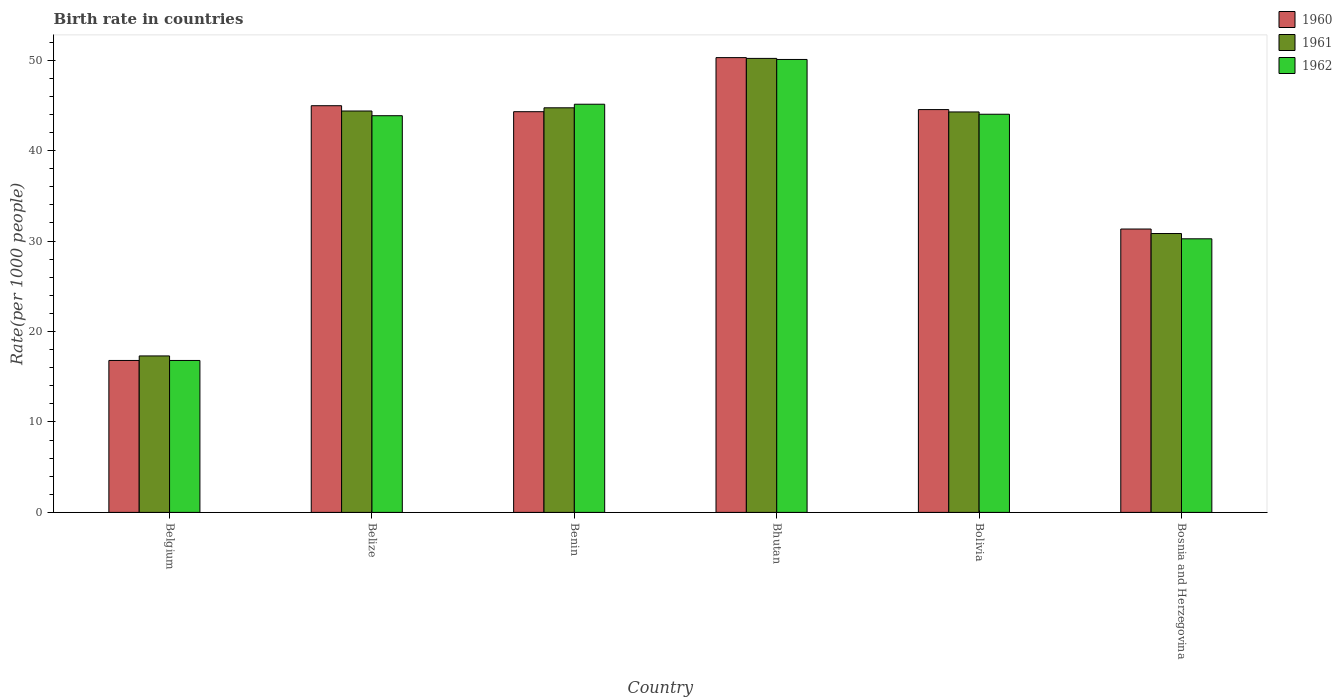How many groups of bars are there?
Offer a very short reply. 6. Are the number of bars on each tick of the X-axis equal?
Your answer should be compact. Yes. How many bars are there on the 3rd tick from the right?
Provide a short and direct response. 3. What is the label of the 2nd group of bars from the left?
Ensure brevity in your answer.  Belize. In how many cases, is the number of bars for a given country not equal to the number of legend labels?
Offer a very short reply. 0. What is the birth rate in 1960 in Bhutan?
Give a very brief answer. 50.29. Across all countries, what is the maximum birth rate in 1960?
Provide a succinct answer. 50.29. In which country was the birth rate in 1961 maximum?
Your answer should be compact. Bhutan. What is the total birth rate in 1961 in the graph?
Offer a very short reply. 231.73. What is the difference between the birth rate in 1961 in Belgium and that in Bhutan?
Make the answer very short. -32.9. What is the difference between the birth rate in 1962 in Bosnia and Herzegovina and the birth rate in 1961 in Benin?
Provide a short and direct response. -14.48. What is the average birth rate in 1962 per country?
Ensure brevity in your answer.  38.36. In how many countries, is the birth rate in 1962 greater than 24?
Offer a terse response. 5. What is the ratio of the birth rate in 1961 in Belgium to that in Bosnia and Herzegovina?
Offer a very short reply. 0.56. Is the birth rate in 1962 in Benin less than that in Bolivia?
Offer a terse response. No. What is the difference between the highest and the second highest birth rate in 1961?
Provide a succinct answer. 5.46. What is the difference between the highest and the lowest birth rate in 1961?
Your answer should be compact. 32.9. What does the 3rd bar from the left in Benin represents?
Provide a short and direct response. 1962. Is it the case that in every country, the sum of the birth rate in 1960 and birth rate in 1962 is greater than the birth rate in 1961?
Provide a succinct answer. Yes. How many bars are there?
Your answer should be compact. 18. Are all the bars in the graph horizontal?
Ensure brevity in your answer.  No. What is the difference between two consecutive major ticks on the Y-axis?
Provide a succinct answer. 10. Are the values on the major ticks of Y-axis written in scientific E-notation?
Offer a very short reply. No. Does the graph contain grids?
Make the answer very short. No. How many legend labels are there?
Offer a very short reply. 3. What is the title of the graph?
Provide a succinct answer. Birth rate in countries. What is the label or title of the Y-axis?
Offer a very short reply. Rate(per 1000 people). What is the Rate(per 1000 people) of 1960 in Belize?
Keep it short and to the point. 44.97. What is the Rate(per 1000 people) of 1961 in Belize?
Your answer should be very brief. 44.38. What is the Rate(per 1000 people) of 1962 in Belize?
Provide a short and direct response. 43.86. What is the Rate(per 1000 people) in 1960 in Benin?
Give a very brief answer. 44.31. What is the Rate(per 1000 people) of 1961 in Benin?
Your response must be concise. 44.74. What is the Rate(per 1000 people) in 1962 in Benin?
Ensure brevity in your answer.  45.13. What is the Rate(per 1000 people) in 1960 in Bhutan?
Offer a very short reply. 50.29. What is the Rate(per 1000 people) of 1961 in Bhutan?
Your response must be concise. 50.2. What is the Rate(per 1000 people) in 1962 in Bhutan?
Provide a short and direct response. 50.08. What is the Rate(per 1000 people) of 1960 in Bolivia?
Offer a very short reply. 44.54. What is the Rate(per 1000 people) of 1961 in Bolivia?
Offer a terse response. 44.28. What is the Rate(per 1000 people) of 1962 in Bolivia?
Ensure brevity in your answer.  44.02. What is the Rate(per 1000 people) of 1960 in Bosnia and Herzegovina?
Make the answer very short. 31.33. What is the Rate(per 1000 people) of 1961 in Bosnia and Herzegovina?
Keep it short and to the point. 30.84. What is the Rate(per 1000 people) of 1962 in Bosnia and Herzegovina?
Make the answer very short. 30.25. Across all countries, what is the maximum Rate(per 1000 people) in 1960?
Give a very brief answer. 50.29. Across all countries, what is the maximum Rate(per 1000 people) of 1961?
Your response must be concise. 50.2. Across all countries, what is the maximum Rate(per 1000 people) in 1962?
Your answer should be compact. 50.08. Across all countries, what is the minimum Rate(per 1000 people) in 1960?
Your response must be concise. 16.8. Across all countries, what is the minimum Rate(per 1000 people) in 1961?
Ensure brevity in your answer.  17.3. Across all countries, what is the minimum Rate(per 1000 people) in 1962?
Your answer should be very brief. 16.8. What is the total Rate(per 1000 people) in 1960 in the graph?
Offer a terse response. 232.23. What is the total Rate(per 1000 people) of 1961 in the graph?
Provide a short and direct response. 231.73. What is the total Rate(per 1000 people) of 1962 in the graph?
Offer a very short reply. 230.15. What is the difference between the Rate(per 1000 people) of 1960 in Belgium and that in Belize?
Offer a terse response. -28.17. What is the difference between the Rate(per 1000 people) of 1961 in Belgium and that in Belize?
Your response must be concise. -27.08. What is the difference between the Rate(per 1000 people) of 1962 in Belgium and that in Belize?
Your response must be concise. -27.06. What is the difference between the Rate(per 1000 people) of 1960 in Belgium and that in Benin?
Your response must be concise. -27.51. What is the difference between the Rate(per 1000 people) of 1961 in Belgium and that in Benin?
Provide a succinct answer. -27.44. What is the difference between the Rate(per 1000 people) in 1962 in Belgium and that in Benin?
Your response must be concise. -28.33. What is the difference between the Rate(per 1000 people) in 1960 in Belgium and that in Bhutan?
Keep it short and to the point. -33.49. What is the difference between the Rate(per 1000 people) of 1961 in Belgium and that in Bhutan?
Provide a short and direct response. -32.9. What is the difference between the Rate(per 1000 people) of 1962 in Belgium and that in Bhutan?
Provide a short and direct response. -33.28. What is the difference between the Rate(per 1000 people) of 1960 in Belgium and that in Bolivia?
Your answer should be very brief. -27.74. What is the difference between the Rate(per 1000 people) in 1961 in Belgium and that in Bolivia?
Make the answer very short. -26.98. What is the difference between the Rate(per 1000 people) of 1962 in Belgium and that in Bolivia?
Provide a succinct answer. -27.23. What is the difference between the Rate(per 1000 people) of 1960 in Belgium and that in Bosnia and Herzegovina?
Your answer should be very brief. -14.53. What is the difference between the Rate(per 1000 people) of 1961 in Belgium and that in Bosnia and Herzegovina?
Offer a terse response. -13.54. What is the difference between the Rate(per 1000 people) in 1962 in Belgium and that in Bosnia and Herzegovina?
Provide a short and direct response. -13.45. What is the difference between the Rate(per 1000 people) in 1960 in Belize and that in Benin?
Your answer should be very brief. 0.66. What is the difference between the Rate(per 1000 people) in 1961 in Belize and that in Benin?
Offer a very short reply. -0.35. What is the difference between the Rate(per 1000 people) of 1962 in Belize and that in Benin?
Keep it short and to the point. -1.27. What is the difference between the Rate(per 1000 people) in 1960 in Belize and that in Bhutan?
Give a very brief answer. -5.32. What is the difference between the Rate(per 1000 people) in 1961 in Belize and that in Bhutan?
Your response must be concise. -5.82. What is the difference between the Rate(per 1000 people) of 1962 in Belize and that in Bhutan?
Give a very brief answer. -6.22. What is the difference between the Rate(per 1000 people) of 1960 in Belize and that in Bolivia?
Provide a short and direct response. 0.43. What is the difference between the Rate(per 1000 people) in 1961 in Belize and that in Bolivia?
Provide a short and direct response. 0.1. What is the difference between the Rate(per 1000 people) in 1962 in Belize and that in Bolivia?
Provide a succinct answer. -0.16. What is the difference between the Rate(per 1000 people) of 1960 in Belize and that in Bosnia and Herzegovina?
Ensure brevity in your answer.  13.63. What is the difference between the Rate(per 1000 people) of 1961 in Belize and that in Bosnia and Herzegovina?
Provide a succinct answer. 13.55. What is the difference between the Rate(per 1000 people) in 1962 in Belize and that in Bosnia and Herzegovina?
Your response must be concise. 13.61. What is the difference between the Rate(per 1000 people) in 1960 in Benin and that in Bhutan?
Make the answer very short. -5.98. What is the difference between the Rate(per 1000 people) in 1961 in Benin and that in Bhutan?
Give a very brief answer. -5.46. What is the difference between the Rate(per 1000 people) of 1962 in Benin and that in Bhutan?
Offer a terse response. -4.95. What is the difference between the Rate(per 1000 people) of 1960 in Benin and that in Bolivia?
Keep it short and to the point. -0.23. What is the difference between the Rate(per 1000 people) in 1961 in Benin and that in Bolivia?
Ensure brevity in your answer.  0.46. What is the difference between the Rate(per 1000 people) in 1962 in Benin and that in Bolivia?
Ensure brevity in your answer.  1.11. What is the difference between the Rate(per 1000 people) of 1960 in Benin and that in Bosnia and Herzegovina?
Provide a short and direct response. 12.97. What is the difference between the Rate(per 1000 people) of 1961 in Benin and that in Bosnia and Herzegovina?
Your answer should be compact. 13.9. What is the difference between the Rate(per 1000 people) of 1962 in Benin and that in Bosnia and Herzegovina?
Make the answer very short. 14.88. What is the difference between the Rate(per 1000 people) in 1960 in Bhutan and that in Bolivia?
Provide a short and direct response. 5.75. What is the difference between the Rate(per 1000 people) in 1961 in Bhutan and that in Bolivia?
Give a very brief answer. 5.92. What is the difference between the Rate(per 1000 people) of 1962 in Bhutan and that in Bolivia?
Your response must be concise. 6.06. What is the difference between the Rate(per 1000 people) of 1960 in Bhutan and that in Bosnia and Herzegovina?
Your response must be concise. 18.95. What is the difference between the Rate(per 1000 people) in 1961 in Bhutan and that in Bosnia and Herzegovina?
Provide a short and direct response. 19.36. What is the difference between the Rate(per 1000 people) of 1962 in Bhutan and that in Bosnia and Herzegovina?
Provide a succinct answer. 19.83. What is the difference between the Rate(per 1000 people) in 1960 in Bolivia and that in Bosnia and Herzegovina?
Offer a very short reply. 13.21. What is the difference between the Rate(per 1000 people) of 1961 in Bolivia and that in Bosnia and Herzegovina?
Provide a succinct answer. 13.44. What is the difference between the Rate(per 1000 people) in 1962 in Bolivia and that in Bosnia and Herzegovina?
Ensure brevity in your answer.  13.77. What is the difference between the Rate(per 1000 people) in 1960 in Belgium and the Rate(per 1000 people) in 1961 in Belize?
Give a very brief answer. -27.58. What is the difference between the Rate(per 1000 people) of 1960 in Belgium and the Rate(per 1000 people) of 1962 in Belize?
Keep it short and to the point. -27.06. What is the difference between the Rate(per 1000 people) of 1961 in Belgium and the Rate(per 1000 people) of 1962 in Belize?
Your response must be concise. -26.56. What is the difference between the Rate(per 1000 people) in 1960 in Belgium and the Rate(per 1000 people) in 1961 in Benin?
Give a very brief answer. -27.94. What is the difference between the Rate(per 1000 people) of 1960 in Belgium and the Rate(per 1000 people) of 1962 in Benin?
Ensure brevity in your answer.  -28.33. What is the difference between the Rate(per 1000 people) in 1961 in Belgium and the Rate(per 1000 people) in 1962 in Benin?
Keep it short and to the point. -27.83. What is the difference between the Rate(per 1000 people) of 1960 in Belgium and the Rate(per 1000 people) of 1961 in Bhutan?
Provide a short and direct response. -33.4. What is the difference between the Rate(per 1000 people) in 1960 in Belgium and the Rate(per 1000 people) in 1962 in Bhutan?
Ensure brevity in your answer.  -33.28. What is the difference between the Rate(per 1000 people) of 1961 in Belgium and the Rate(per 1000 people) of 1962 in Bhutan?
Your answer should be very brief. -32.78. What is the difference between the Rate(per 1000 people) in 1960 in Belgium and the Rate(per 1000 people) in 1961 in Bolivia?
Make the answer very short. -27.48. What is the difference between the Rate(per 1000 people) in 1960 in Belgium and the Rate(per 1000 people) in 1962 in Bolivia?
Your answer should be compact. -27.23. What is the difference between the Rate(per 1000 people) of 1961 in Belgium and the Rate(per 1000 people) of 1962 in Bolivia?
Provide a short and direct response. -26.73. What is the difference between the Rate(per 1000 people) of 1960 in Belgium and the Rate(per 1000 people) of 1961 in Bosnia and Herzegovina?
Your response must be concise. -14.04. What is the difference between the Rate(per 1000 people) in 1960 in Belgium and the Rate(per 1000 people) in 1962 in Bosnia and Herzegovina?
Your answer should be very brief. -13.45. What is the difference between the Rate(per 1000 people) in 1961 in Belgium and the Rate(per 1000 people) in 1962 in Bosnia and Herzegovina?
Offer a very short reply. -12.95. What is the difference between the Rate(per 1000 people) of 1960 in Belize and the Rate(per 1000 people) of 1961 in Benin?
Your answer should be very brief. 0.23. What is the difference between the Rate(per 1000 people) of 1960 in Belize and the Rate(per 1000 people) of 1962 in Benin?
Keep it short and to the point. -0.17. What is the difference between the Rate(per 1000 people) of 1961 in Belize and the Rate(per 1000 people) of 1962 in Benin?
Provide a succinct answer. -0.75. What is the difference between the Rate(per 1000 people) in 1960 in Belize and the Rate(per 1000 people) in 1961 in Bhutan?
Offer a terse response. -5.23. What is the difference between the Rate(per 1000 people) in 1960 in Belize and the Rate(per 1000 people) in 1962 in Bhutan?
Offer a terse response. -5.11. What is the difference between the Rate(per 1000 people) of 1961 in Belize and the Rate(per 1000 people) of 1962 in Bhutan?
Your answer should be compact. -5.7. What is the difference between the Rate(per 1000 people) in 1960 in Belize and the Rate(per 1000 people) in 1961 in Bolivia?
Your answer should be very brief. 0.69. What is the difference between the Rate(per 1000 people) of 1960 in Belize and the Rate(per 1000 people) of 1962 in Bolivia?
Keep it short and to the point. 0.94. What is the difference between the Rate(per 1000 people) in 1961 in Belize and the Rate(per 1000 people) in 1962 in Bolivia?
Your answer should be compact. 0.36. What is the difference between the Rate(per 1000 people) of 1960 in Belize and the Rate(per 1000 people) of 1961 in Bosnia and Herzegovina?
Offer a very short reply. 14.13. What is the difference between the Rate(per 1000 people) in 1960 in Belize and the Rate(per 1000 people) in 1962 in Bosnia and Herzegovina?
Provide a succinct answer. 14.71. What is the difference between the Rate(per 1000 people) of 1961 in Belize and the Rate(per 1000 people) of 1962 in Bosnia and Herzegovina?
Your response must be concise. 14.13. What is the difference between the Rate(per 1000 people) in 1960 in Benin and the Rate(per 1000 people) in 1961 in Bhutan?
Keep it short and to the point. -5.89. What is the difference between the Rate(per 1000 people) in 1960 in Benin and the Rate(per 1000 people) in 1962 in Bhutan?
Offer a very short reply. -5.77. What is the difference between the Rate(per 1000 people) in 1961 in Benin and the Rate(per 1000 people) in 1962 in Bhutan?
Your answer should be compact. -5.34. What is the difference between the Rate(per 1000 people) of 1960 in Benin and the Rate(per 1000 people) of 1961 in Bolivia?
Offer a terse response. 0.03. What is the difference between the Rate(per 1000 people) in 1960 in Benin and the Rate(per 1000 people) in 1962 in Bolivia?
Offer a very short reply. 0.28. What is the difference between the Rate(per 1000 people) in 1961 in Benin and the Rate(per 1000 people) in 1962 in Bolivia?
Give a very brief answer. 0.71. What is the difference between the Rate(per 1000 people) of 1960 in Benin and the Rate(per 1000 people) of 1961 in Bosnia and Herzegovina?
Keep it short and to the point. 13.47. What is the difference between the Rate(per 1000 people) of 1960 in Benin and the Rate(per 1000 people) of 1962 in Bosnia and Herzegovina?
Provide a succinct answer. 14.05. What is the difference between the Rate(per 1000 people) in 1961 in Benin and the Rate(per 1000 people) in 1962 in Bosnia and Herzegovina?
Give a very brief answer. 14.48. What is the difference between the Rate(per 1000 people) in 1960 in Bhutan and the Rate(per 1000 people) in 1961 in Bolivia?
Ensure brevity in your answer.  6.01. What is the difference between the Rate(per 1000 people) in 1960 in Bhutan and the Rate(per 1000 people) in 1962 in Bolivia?
Ensure brevity in your answer.  6.26. What is the difference between the Rate(per 1000 people) in 1961 in Bhutan and the Rate(per 1000 people) in 1962 in Bolivia?
Your answer should be compact. 6.17. What is the difference between the Rate(per 1000 people) in 1960 in Bhutan and the Rate(per 1000 people) in 1961 in Bosnia and Herzegovina?
Your response must be concise. 19.45. What is the difference between the Rate(per 1000 people) in 1960 in Bhutan and the Rate(per 1000 people) in 1962 in Bosnia and Herzegovina?
Give a very brief answer. 20.03. What is the difference between the Rate(per 1000 people) in 1961 in Bhutan and the Rate(per 1000 people) in 1962 in Bosnia and Herzegovina?
Offer a terse response. 19.95. What is the difference between the Rate(per 1000 people) of 1960 in Bolivia and the Rate(per 1000 people) of 1961 in Bosnia and Herzegovina?
Offer a very short reply. 13.7. What is the difference between the Rate(per 1000 people) in 1960 in Bolivia and the Rate(per 1000 people) in 1962 in Bosnia and Herzegovina?
Provide a succinct answer. 14.29. What is the difference between the Rate(per 1000 people) in 1961 in Bolivia and the Rate(per 1000 people) in 1962 in Bosnia and Herzegovina?
Provide a succinct answer. 14.03. What is the average Rate(per 1000 people) of 1960 per country?
Provide a succinct answer. 38.71. What is the average Rate(per 1000 people) in 1961 per country?
Keep it short and to the point. 38.62. What is the average Rate(per 1000 people) in 1962 per country?
Offer a very short reply. 38.36. What is the difference between the Rate(per 1000 people) of 1960 and Rate(per 1000 people) of 1961 in Belgium?
Provide a succinct answer. -0.5. What is the difference between the Rate(per 1000 people) in 1960 and Rate(per 1000 people) in 1962 in Belgium?
Offer a very short reply. 0. What is the difference between the Rate(per 1000 people) in 1961 and Rate(per 1000 people) in 1962 in Belgium?
Your answer should be compact. 0.5. What is the difference between the Rate(per 1000 people) of 1960 and Rate(per 1000 people) of 1961 in Belize?
Ensure brevity in your answer.  0.58. What is the difference between the Rate(per 1000 people) of 1960 and Rate(per 1000 people) of 1962 in Belize?
Make the answer very short. 1.1. What is the difference between the Rate(per 1000 people) in 1961 and Rate(per 1000 people) in 1962 in Belize?
Offer a terse response. 0.52. What is the difference between the Rate(per 1000 people) in 1960 and Rate(per 1000 people) in 1961 in Benin?
Provide a short and direct response. -0.43. What is the difference between the Rate(per 1000 people) in 1960 and Rate(per 1000 people) in 1962 in Benin?
Your answer should be compact. -0.82. What is the difference between the Rate(per 1000 people) of 1961 and Rate(per 1000 people) of 1962 in Benin?
Offer a very short reply. -0.4. What is the difference between the Rate(per 1000 people) of 1960 and Rate(per 1000 people) of 1961 in Bhutan?
Give a very brief answer. 0.09. What is the difference between the Rate(per 1000 people) in 1960 and Rate(per 1000 people) in 1962 in Bhutan?
Ensure brevity in your answer.  0.2. What is the difference between the Rate(per 1000 people) of 1961 and Rate(per 1000 people) of 1962 in Bhutan?
Make the answer very short. 0.12. What is the difference between the Rate(per 1000 people) in 1960 and Rate(per 1000 people) in 1961 in Bolivia?
Make the answer very short. 0.26. What is the difference between the Rate(per 1000 people) of 1960 and Rate(per 1000 people) of 1962 in Bolivia?
Your answer should be very brief. 0.51. What is the difference between the Rate(per 1000 people) in 1961 and Rate(per 1000 people) in 1962 in Bolivia?
Give a very brief answer. 0.25. What is the difference between the Rate(per 1000 people) of 1960 and Rate(per 1000 people) of 1961 in Bosnia and Herzegovina?
Give a very brief answer. 0.5. What is the difference between the Rate(per 1000 people) of 1960 and Rate(per 1000 people) of 1962 in Bosnia and Herzegovina?
Offer a terse response. 1.08. What is the difference between the Rate(per 1000 people) in 1961 and Rate(per 1000 people) in 1962 in Bosnia and Herzegovina?
Your answer should be compact. 0.58. What is the ratio of the Rate(per 1000 people) of 1960 in Belgium to that in Belize?
Give a very brief answer. 0.37. What is the ratio of the Rate(per 1000 people) in 1961 in Belgium to that in Belize?
Provide a short and direct response. 0.39. What is the ratio of the Rate(per 1000 people) in 1962 in Belgium to that in Belize?
Provide a succinct answer. 0.38. What is the ratio of the Rate(per 1000 people) of 1960 in Belgium to that in Benin?
Your answer should be compact. 0.38. What is the ratio of the Rate(per 1000 people) of 1961 in Belgium to that in Benin?
Provide a succinct answer. 0.39. What is the ratio of the Rate(per 1000 people) in 1962 in Belgium to that in Benin?
Provide a succinct answer. 0.37. What is the ratio of the Rate(per 1000 people) in 1960 in Belgium to that in Bhutan?
Offer a terse response. 0.33. What is the ratio of the Rate(per 1000 people) of 1961 in Belgium to that in Bhutan?
Ensure brevity in your answer.  0.34. What is the ratio of the Rate(per 1000 people) of 1962 in Belgium to that in Bhutan?
Ensure brevity in your answer.  0.34. What is the ratio of the Rate(per 1000 people) in 1960 in Belgium to that in Bolivia?
Provide a succinct answer. 0.38. What is the ratio of the Rate(per 1000 people) of 1961 in Belgium to that in Bolivia?
Your response must be concise. 0.39. What is the ratio of the Rate(per 1000 people) in 1962 in Belgium to that in Bolivia?
Ensure brevity in your answer.  0.38. What is the ratio of the Rate(per 1000 people) of 1960 in Belgium to that in Bosnia and Herzegovina?
Provide a succinct answer. 0.54. What is the ratio of the Rate(per 1000 people) in 1961 in Belgium to that in Bosnia and Herzegovina?
Give a very brief answer. 0.56. What is the ratio of the Rate(per 1000 people) in 1962 in Belgium to that in Bosnia and Herzegovina?
Offer a terse response. 0.56. What is the ratio of the Rate(per 1000 people) of 1960 in Belize to that in Benin?
Make the answer very short. 1.01. What is the ratio of the Rate(per 1000 people) in 1962 in Belize to that in Benin?
Provide a short and direct response. 0.97. What is the ratio of the Rate(per 1000 people) in 1960 in Belize to that in Bhutan?
Offer a very short reply. 0.89. What is the ratio of the Rate(per 1000 people) in 1961 in Belize to that in Bhutan?
Make the answer very short. 0.88. What is the ratio of the Rate(per 1000 people) of 1962 in Belize to that in Bhutan?
Your answer should be compact. 0.88. What is the ratio of the Rate(per 1000 people) in 1960 in Belize to that in Bolivia?
Keep it short and to the point. 1.01. What is the ratio of the Rate(per 1000 people) in 1961 in Belize to that in Bolivia?
Your answer should be very brief. 1. What is the ratio of the Rate(per 1000 people) of 1962 in Belize to that in Bolivia?
Offer a very short reply. 1. What is the ratio of the Rate(per 1000 people) of 1960 in Belize to that in Bosnia and Herzegovina?
Ensure brevity in your answer.  1.44. What is the ratio of the Rate(per 1000 people) of 1961 in Belize to that in Bosnia and Herzegovina?
Your answer should be very brief. 1.44. What is the ratio of the Rate(per 1000 people) in 1962 in Belize to that in Bosnia and Herzegovina?
Your answer should be compact. 1.45. What is the ratio of the Rate(per 1000 people) of 1960 in Benin to that in Bhutan?
Your answer should be very brief. 0.88. What is the ratio of the Rate(per 1000 people) of 1961 in Benin to that in Bhutan?
Ensure brevity in your answer.  0.89. What is the ratio of the Rate(per 1000 people) of 1962 in Benin to that in Bhutan?
Provide a succinct answer. 0.9. What is the ratio of the Rate(per 1000 people) of 1960 in Benin to that in Bolivia?
Provide a short and direct response. 0.99. What is the ratio of the Rate(per 1000 people) of 1961 in Benin to that in Bolivia?
Offer a very short reply. 1.01. What is the ratio of the Rate(per 1000 people) of 1962 in Benin to that in Bolivia?
Ensure brevity in your answer.  1.03. What is the ratio of the Rate(per 1000 people) of 1960 in Benin to that in Bosnia and Herzegovina?
Give a very brief answer. 1.41. What is the ratio of the Rate(per 1000 people) of 1961 in Benin to that in Bosnia and Herzegovina?
Your answer should be compact. 1.45. What is the ratio of the Rate(per 1000 people) in 1962 in Benin to that in Bosnia and Herzegovina?
Make the answer very short. 1.49. What is the ratio of the Rate(per 1000 people) in 1960 in Bhutan to that in Bolivia?
Your answer should be very brief. 1.13. What is the ratio of the Rate(per 1000 people) of 1961 in Bhutan to that in Bolivia?
Provide a short and direct response. 1.13. What is the ratio of the Rate(per 1000 people) in 1962 in Bhutan to that in Bolivia?
Your response must be concise. 1.14. What is the ratio of the Rate(per 1000 people) in 1960 in Bhutan to that in Bosnia and Herzegovina?
Offer a terse response. 1.6. What is the ratio of the Rate(per 1000 people) in 1961 in Bhutan to that in Bosnia and Herzegovina?
Offer a very short reply. 1.63. What is the ratio of the Rate(per 1000 people) in 1962 in Bhutan to that in Bosnia and Herzegovina?
Your answer should be very brief. 1.66. What is the ratio of the Rate(per 1000 people) of 1960 in Bolivia to that in Bosnia and Herzegovina?
Your answer should be very brief. 1.42. What is the ratio of the Rate(per 1000 people) of 1961 in Bolivia to that in Bosnia and Herzegovina?
Offer a terse response. 1.44. What is the ratio of the Rate(per 1000 people) in 1962 in Bolivia to that in Bosnia and Herzegovina?
Make the answer very short. 1.46. What is the difference between the highest and the second highest Rate(per 1000 people) of 1960?
Offer a terse response. 5.32. What is the difference between the highest and the second highest Rate(per 1000 people) of 1961?
Offer a terse response. 5.46. What is the difference between the highest and the second highest Rate(per 1000 people) in 1962?
Your answer should be very brief. 4.95. What is the difference between the highest and the lowest Rate(per 1000 people) of 1960?
Give a very brief answer. 33.49. What is the difference between the highest and the lowest Rate(per 1000 people) in 1961?
Provide a short and direct response. 32.9. What is the difference between the highest and the lowest Rate(per 1000 people) of 1962?
Provide a succinct answer. 33.28. 